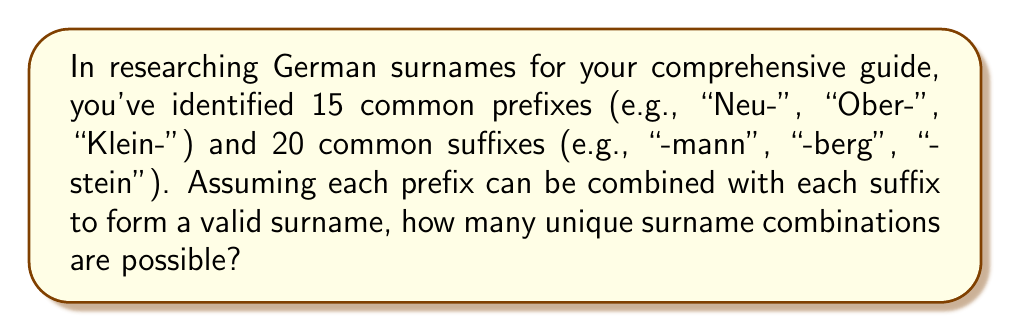Solve this math problem. To solve this problem, we can use the fundamental counting principle from field theory. This principle states that if we have two independent events, where one event can occur in $m$ ways and the other in $n$ ways, then the total number of ways both events can occur is $m \times n$.

In this case:
1. We have 15 prefixes, so $m = 15$
2. We have 20 suffixes, so $n = 20$
3. Each prefix can be combined with each suffix

Therefore, the total number of unique surname combinations is:

$$\text{Total combinations} = \text{Number of prefixes} \times \text{Number of suffixes}$$

$$\text{Total combinations} = 15 \times 20 = 300$$

This multiplication ensures that every possible combination of prefix and suffix is counted exactly once, giving us the total number of unique surname combinations.
Answer: 300 unique combinations 